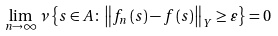Convert formula to latex. <formula><loc_0><loc_0><loc_500><loc_500>\lim _ { n \rightarrow \infty } \nu \left \{ s \in A \colon \left \| f _ { n } \left ( s \right ) - f \left ( s \right ) \right \| _ { Y } \geq \varepsilon \right \} = 0</formula> 